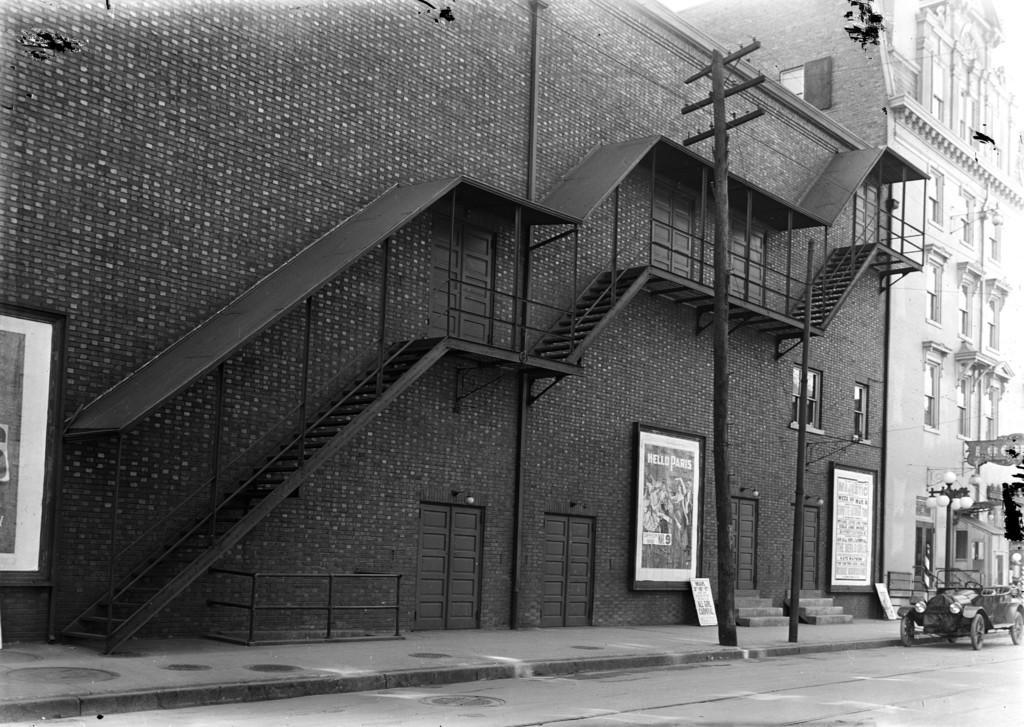In one or two sentences, can you explain what this image depicts? In this picture there is a building in the center of the image, on which there are doors and a staircase, there are posters on the building and there is another building on the right side of the image and there is a jeep and a lamp pole on the right side of the image. 